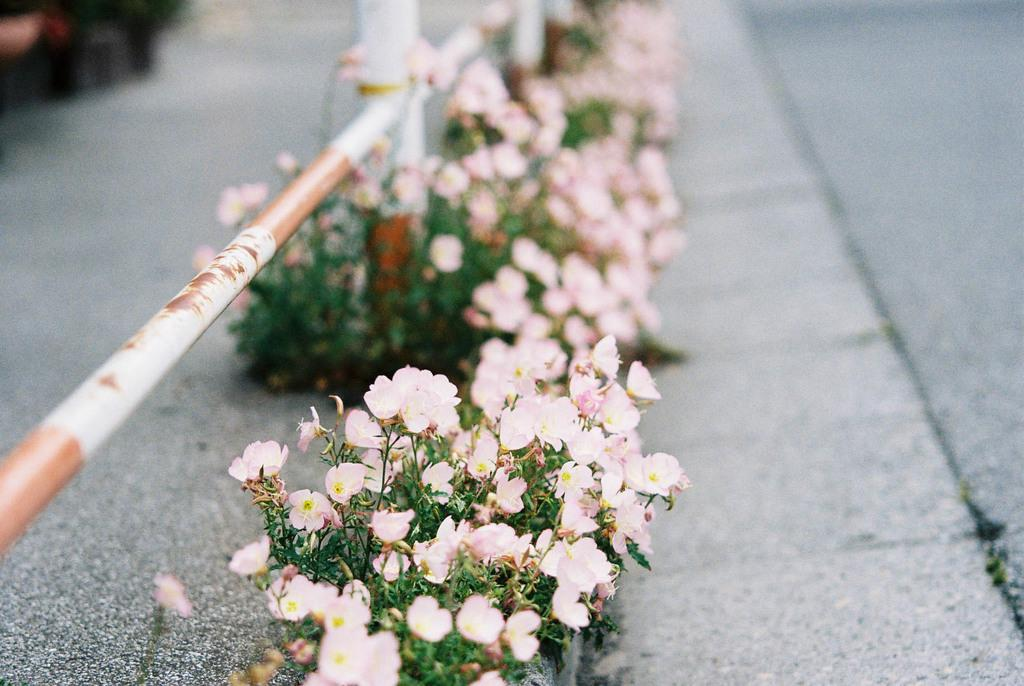What type of plants can be seen in the image? There are small plants with flowers in the image. What color are the flowers on the plants? The flowers are light pink in color. What object can be seen in the image that is made of metal? There appears to be an iron pole in the image. Can you describe the setting or location depicted in the image? The image may depict a road. Are there any apples growing on the plants in the image? There is no mention of apples in the image; the plants have flowers, not fruit. Can you see any string used to tie the plants together in the image? There is no string visible in the image; the plants are not tied together. 